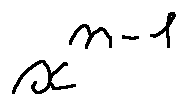Convert formula to latex. <formula><loc_0><loc_0><loc_500><loc_500>x ^ { n - 1 }</formula> 